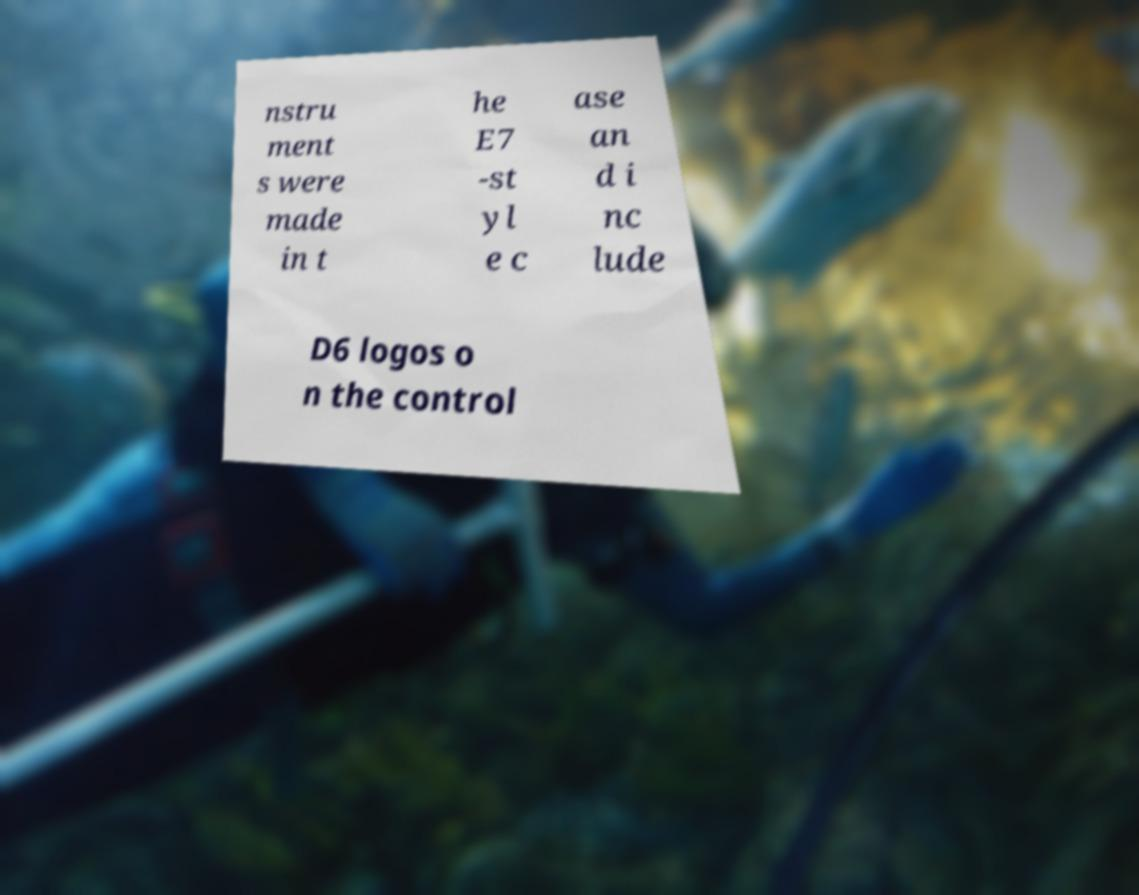What messages or text are displayed in this image? I need them in a readable, typed format. nstru ment s were made in t he E7 -st yl e c ase an d i nc lude D6 logos o n the control 